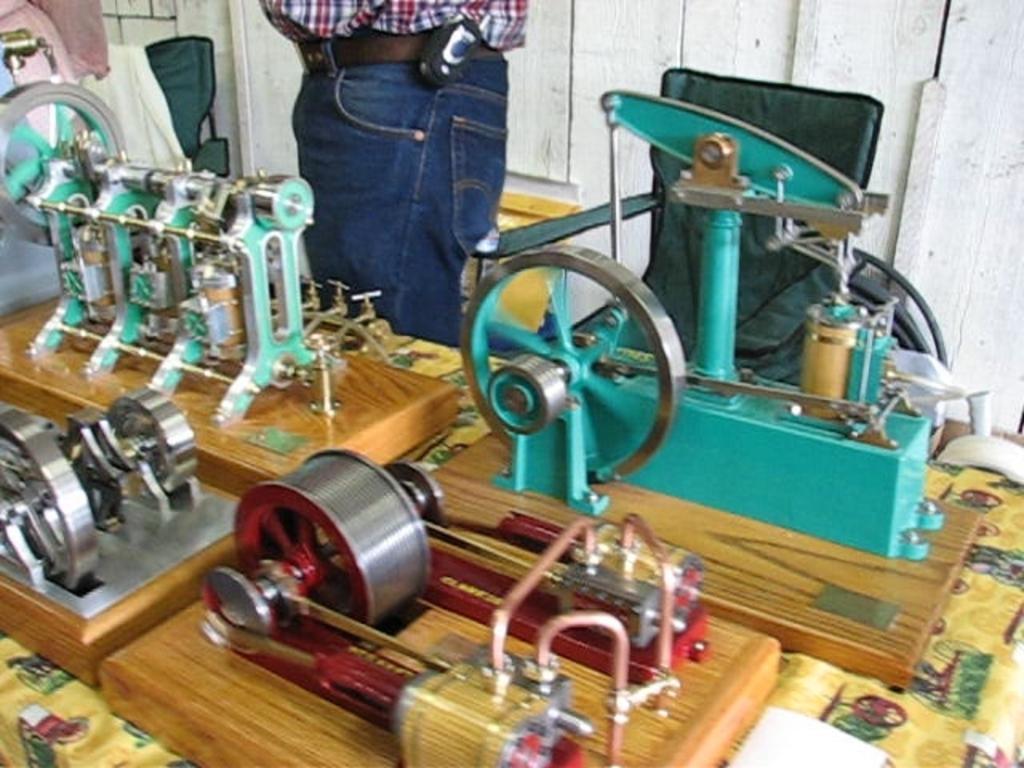Can you describe this image briefly? In the image, on the table there are machines. Behind the table there is a man standing and also there is a chair. 